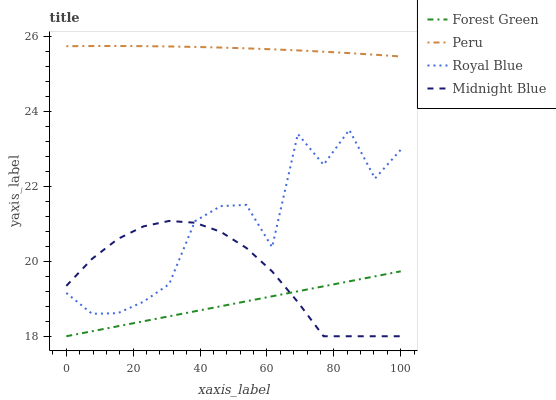Does Forest Green have the minimum area under the curve?
Answer yes or no. Yes. Does Peru have the maximum area under the curve?
Answer yes or no. Yes. Does Midnight Blue have the minimum area under the curve?
Answer yes or no. No. Does Midnight Blue have the maximum area under the curve?
Answer yes or no. No. Is Forest Green the smoothest?
Answer yes or no. Yes. Is Royal Blue the roughest?
Answer yes or no. Yes. Is Midnight Blue the smoothest?
Answer yes or no. No. Is Midnight Blue the roughest?
Answer yes or no. No. Does Forest Green have the lowest value?
Answer yes or no. Yes. Does Peru have the lowest value?
Answer yes or no. No. Does Peru have the highest value?
Answer yes or no. Yes. Does Midnight Blue have the highest value?
Answer yes or no. No. Is Royal Blue less than Peru?
Answer yes or no. Yes. Is Royal Blue greater than Forest Green?
Answer yes or no. Yes. Does Royal Blue intersect Midnight Blue?
Answer yes or no. Yes. Is Royal Blue less than Midnight Blue?
Answer yes or no. No. Is Royal Blue greater than Midnight Blue?
Answer yes or no. No. Does Royal Blue intersect Peru?
Answer yes or no. No. 